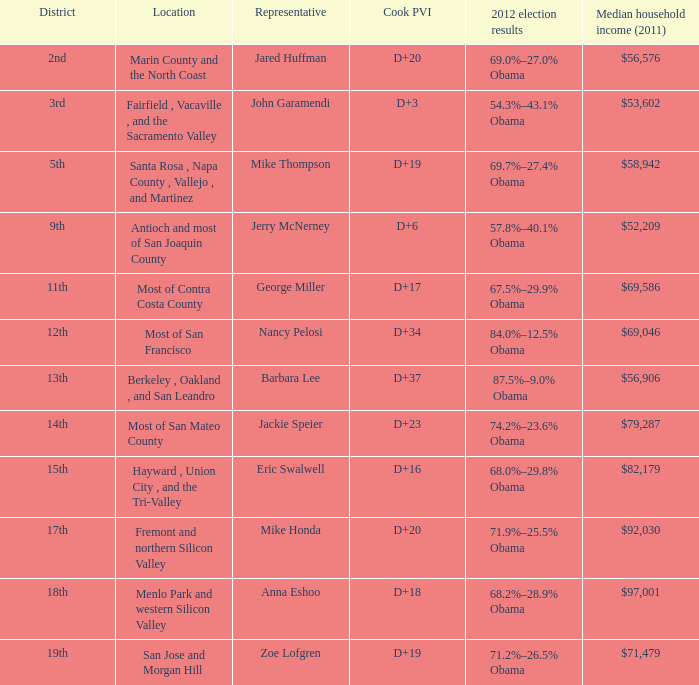In the 2012 election, what were the outcomes for locations with barbara lee as their representative? 87.5%–9.0% Obama. 